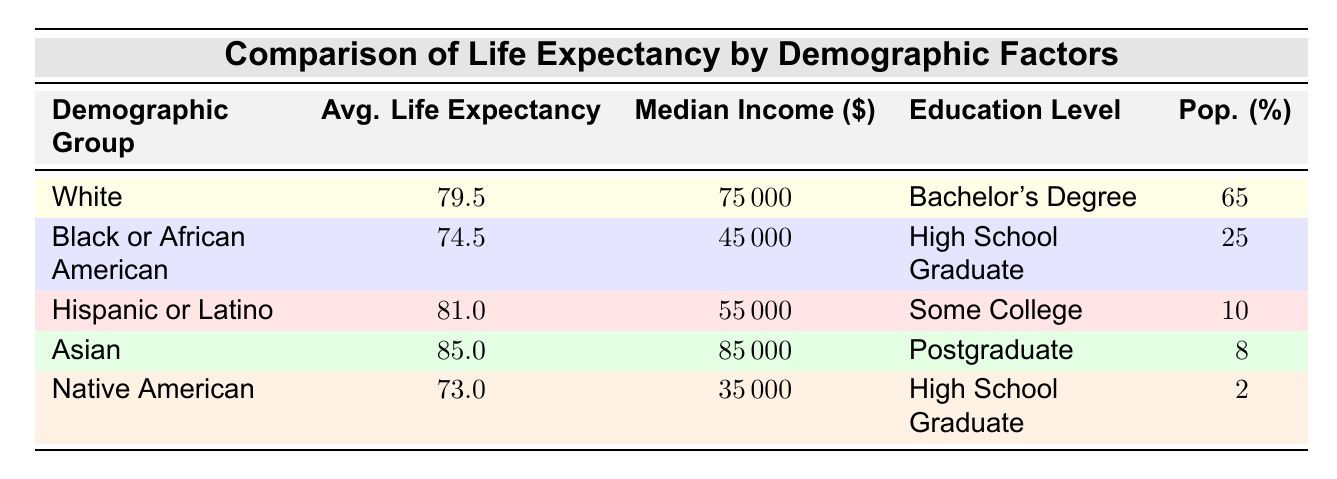What is the average life expectancy for the Asian demographic group? The table lists the average life expectancy for each demographic group, and for the Asian group, it shows an average life expectancy of 85.0.
Answer: 85.0 Which demographic group has the highest median income? By comparing the median income values across all groups, the Asian demographic group has the highest median income at 85000.
Answer: Asian What is the average life expectancy difference between the White and Black or African American groups? The average life expectancy for the White group is 79.5, and for the Black or African American group, it is 74.5. The difference is calculated as 79.5 - 74.5 = 5.0.
Answer: 5.0 Is the education level of the Hispanic or Latino demographic group higher or lower than that of the Native American group? The Hispanic or Latino demographic group has an education level of "Some College," while the Native American group has "High School Graduate." Since "Some College" is typically considered higher than "High School Graduate," the answer is that the education level is higher.
Answer: Higher What is the average life expectancy of the groups with a median income of 45000 or less? The Black or African American group has an average life expectancy of 74.5, and the Native American group has an average life expectancy of 73.0. The average of these two values is (74.5 + 73.0) / 2 = 73.75.
Answer: 73.75 Which demographic group represents the lowest percentage of the population? The Native American demographic group has the lowest population percentage, which is 2 percent.
Answer: Native American What is the average life expectancy of the three groups with the highest life expectancy? The average life expectancy for the three highest groups (Asian 85.0, Hispanic or Latino 81.0, White 79.5) is calculated as (85.0 + 81.0 + 79.5) / 3 = 81.5.
Answer: 81.5 Is the average life expectancy for Hispanic or Latino group higher than that of the Black or African American group? The average life expectancy for the Hispanic or Latino group is 81.0, while for the Black or African American group it is 74.5. Since 81.0 is greater than 74.5, the statement is true.
Answer: Yes 